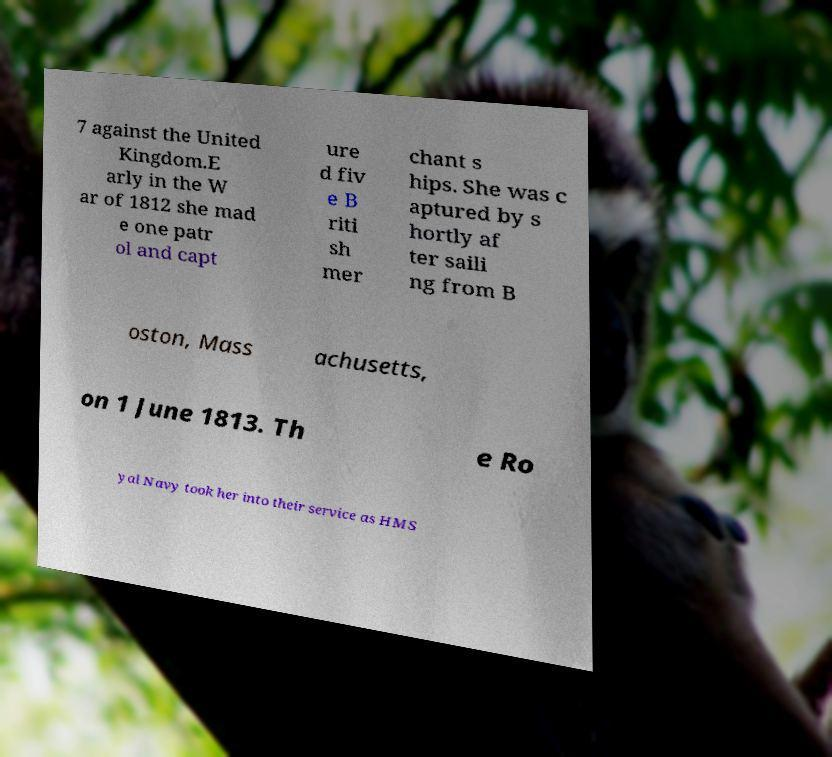Could you extract and type out the text from this image? 7 against the United Kingdom.E arly in the W ar of 1812 she mad e one patr ol and capt ure d fiv e B riti sh mer chant s hips. She was c aptured by s hortly af ter saili ng from B oston, Mass achusetts, on 1 June 1813. Th e Ro yal Navy took her into their service as HMS 